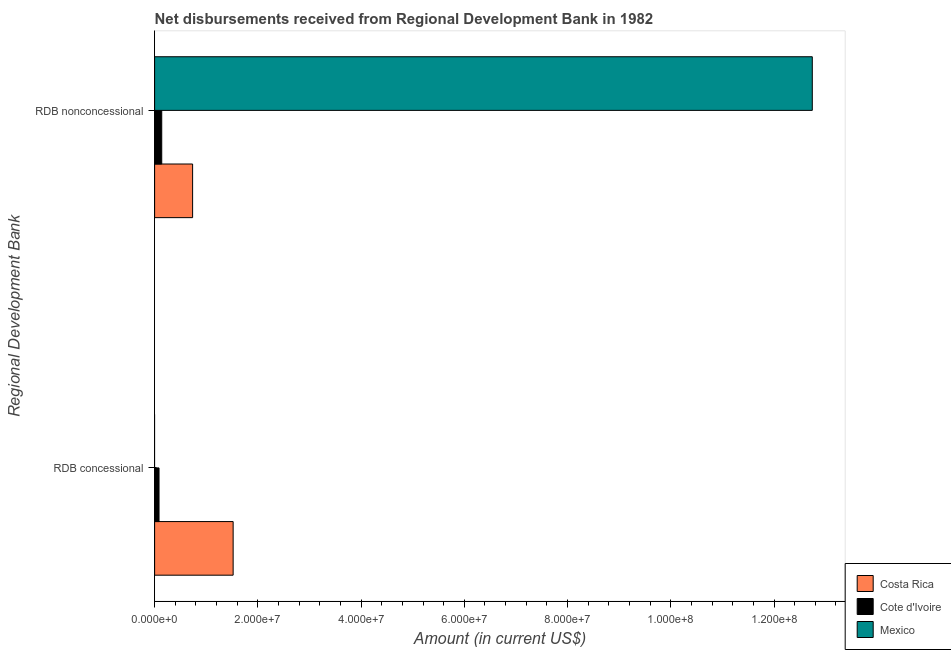How many different coloured bars are there?
Your answer should be compact. 3. How many groups of bars are there?
Give a very brief answer. 2. Are the number of bars per tick equal to the number of legend labels?
Offer a terse response. No. Are the number of bars on each tick of the Y-axis equal?
Your response must be concise. No. What is the label of the 1st group of bars from the top?
Your response must be concise. RDB nonconcessional. What is the net concessional disbursements from rdb in Costa Rica?
Give a very brief answer. 1.52e+07. Across all countries, what is the maximum net concessional disbursements from rdb?
Keep it short and to the point. 1.52e+07. Across all countries, what is the minimum net non concessional disbursements from rdb?
Your answer should be very brief. 1.38e+06. In which country was the net non concessional disbursements from rdb maximum?
Your answer should be very brief. Mexico. What is the total net non concessional disbursements from rdb in the graph?
Your answer should be very brief. 1.36e+08. What is the difference between the net concessional disbursements from rdb in Costa Rica and that in Cote d'Ivoire?
Your answer should be compact. 1.44e+07. What is the difference between the net non concessional disbursements from rdb in Mexico and the net concessional disbursements from rdb in Costa Rica?
Give a very brief answer. 1.12e+08. What is the average net non concessional disbursements from rdb per country?
Provide a short and direct response. 4.54e+07. What is the difference between the net non concessional disbursements from rdb and net concessional disbursements from rdb in Cote d'Ivoire?
Offer a very short reply. 5.24e+05. What is the ratio of the net concessional disbursements from rdb in Costa Rica to that in Cote d'Ivoire?
Give a very brief answer. 17.77. Is the net non concessional disbursements from rdb in Costa Rica less than that in Mexico?
Offer a terse response. Yes. In how many countries, is the net concessional disbursements from rdb greater than the average net concessional disbursements from rdb taken over all countries?
Provide a succinct answer. 1. Are all the bars in the graph horizontal?
Provide a short and direct response. Yes. How many countries are there in the graph?
Offer a very short reply. 3. What is the difference between two consecutive major ticks on the X-axis?
Your answer should be very brief. 2.00e+07. Are the values on the major ticks of X-axis written in scientific E-notation?
Your answer should be compact. Yes. Does the graph contain any zero values?
Provide a succinct answer. Yes. Where does the legend appear in the graph?
Provide a succinct answer. Bottom right. How are the legend labels stacked?
Provide a succinct answer. Vertical. What is the title of the graph?
Offer a terse response. Net disbursements received from Regional Development Bank in 1982. What is the label or title of the X-axis?
Keep it short and to the point. Amount (in current US$). What is the label or title of the Y-axis?
Your response must be concise. Regional Development Bank. What is the Amount (in current US$) of Costa Rica in RDB concessional?
Your answer should be compact. 1.52e+07. What is the Amount (in current US$) of Cote d'Ivoire in RDB concessional?
Keep it short and to the point. 8.56e+05. What is the Amount (in current US$) of Costa Rica in RDB nonconcessional?
Give a very brief answer. 7.36e+06. What is the Amount (in current US$) in Cote d'Ivoire in RDB nonconcessional?
Provide a short and direct response. 1.38e+06. What is the Amount (in current US$) of Mexico in RDB nonconcessional?
Keep it short and to the point. 1.27e+08. Across all Regional Development Bank, what is the maximum Amount (in current US$) in Costa Rica?
Offer a terse response. 1.52e+07. Across all Regional Development Bank, what is the maximum Amount (in current US$) of Cote d'Ivoire?
Provide a succinct answer. 1.38e+06. Across all Regional Development Bank, what is the maximum Amount (in current US$) of Mexico?
Provide a succinct answer. 1.27e+08. Across all Regional Development Bank, what is the minimum Amount (in current US$) of Costa Rica?
Keep it short and to the point. 7.36e+06. Across all Regional Development Bank, what is the minimum Amount (in current US$) of Cote d'Ivoire?
Your answer should be very brief. 8.56e+05. What is the total Amount (in current US$) in Costa Rica in the graph?
Offer a very short reply. 2.26e+07. What is the total Amount (in current US$) of Cote d'Ivoire in the graph?
Your answer should be compact. 2.24e+06. What is the total Amount (in current US$) of Mexico in the graph?
Your answer should be compact. 1.27e+08. What is the difference between the Amount (in current US$) of Costa Rica in RDB concessional and that in RDB nonconcessional?
Ensure brevity in your answer.  7.85e+06. What is the difference between the Amount (in current US$) in Cote d'Ivoire in RDB concessional and that in RDB nonconcessional?
Keep it short and to the point. -5.24e+05. What is the difference between the Amount (in current US$) in Costa Rica in RDB concessional and the Amount (in current US$) in Cote d'Ivoire in RDB nonconcessional?
Provide a short and direct response. 1.38e+07. What is the difference between the Amount (in current US$) in Costa Rica in RDB concessional and the Amount (in current US$) in Mexico in RDB nonconcessional?
Your answer should be very brief. -1.12e+08. What is the difference between the Amount (in current US$) in Cote d'Ivoire in RDB concessional and the Amount (in current US$) in Mexico in RDB nonconcessional?
Provide a succinct answer. -1.27e+08. What is the average Amount (in current US$) of Costa Rica per Regional Development Bank?
Provide a succinct answer. 1.13e+07. What is the average Amount (in current US$) in Cote d'Ivoire per Regional Development Bank?
Your response must be concise. 1.12e+06. What is the average Amount (in current US$) in Mexico per Regional Development Bank?
Offer a terse response. 6.37e+07. What is the difference between the Amount (in current US$) of Costa Rica and Amount (in current US$) of Cote d'Ivoire in RDB concessional?
Provide a succinct answer. 1.44e+07. What is the difference between the Amount (in current US$) in Costa Rica and Amount (in current US$) in Cote d'Ivoire in RDB nonconcessional?
Your answer should be very brief. 5.98e+06. What is the difference between the Amount (in current US$) in Costa Rica and Amount (in current US$) in Mexico in RDB nonconcessional?
Offer a very short reply. -1.20e+08. What is the difference between the Amount (in current US$) of Cote d'Ivoire and Amount (in current US$) of Mexico in RDB nonconcessional?
Give a very brief answer. -1.26e+08. What is the ratio of the Amount (in current US$) in Costa Rica in RDB concessional to that in RDB nonconcessional?
Make the answer very short. 2.07. What is the ratio of the Amount (in current US$) of Cote d'Ivoire in RDB concessional to that in RDB nonconcessional?
Keep it short and to the point. 0.62. What is the difference between the highest and the second highest Amount (in current US$) of Costa Rica?
Your answer should be very brief. 7.85e+06. What is the difference between the highest and the second highest Amount (in current US$) of Cote d'Ivoire?
Provide a short and direct response. 5.24e+05. What is the difference between the highest and the lowest Amount (in current US$) in Costa Rica?
Provide a short and direct response. 7.85e+06. What is the difference between the highest and the lowest Amount (in current US$) of Cote d'Ivoire?
Your response must be concise. 5.24e+05. What is the difference between the highest and the lowest Amount (in current US$) of Mexico?
Provide a short and direct response. 1.27e+08. 